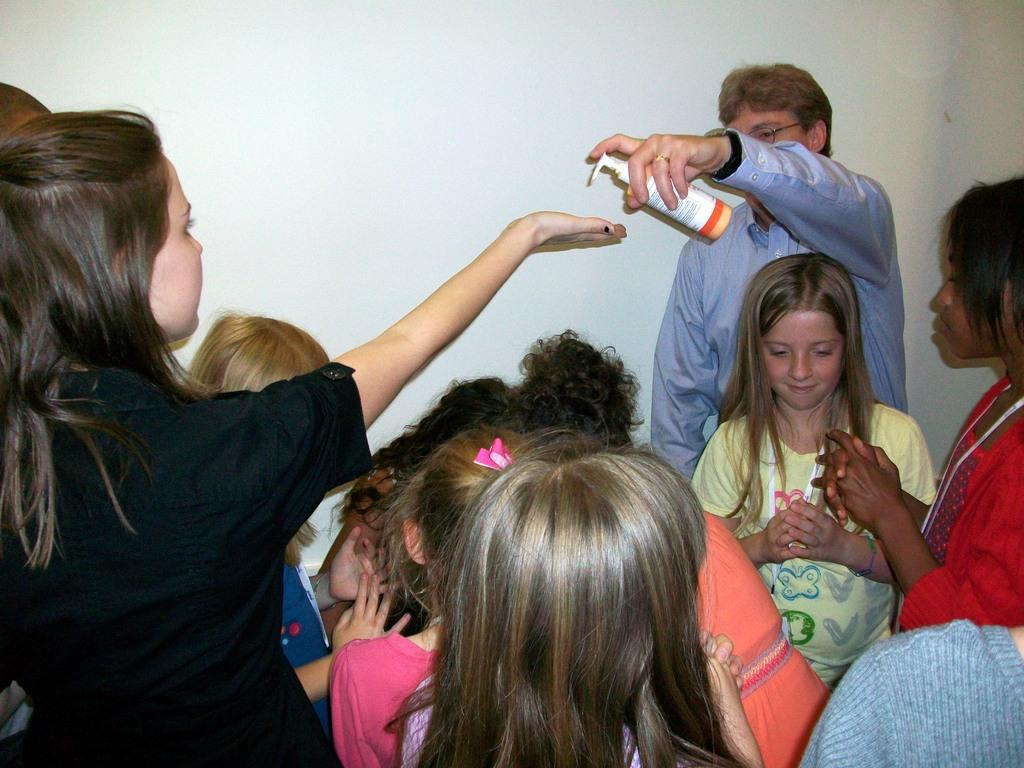How many people are in the image? There are a few people in the image. Can you describe one of the people in the image? One person is wearing spectacles. What is the person wearing spectacles holding? The person wearing spectacles is holding a bottle. What can be seen in the background of the image? There is a wall in the background of the image. What type of cabbage is growing on the edge of the wall in the image? There is no cabbage present in the image, and the wall does not have any plants growing on it. 